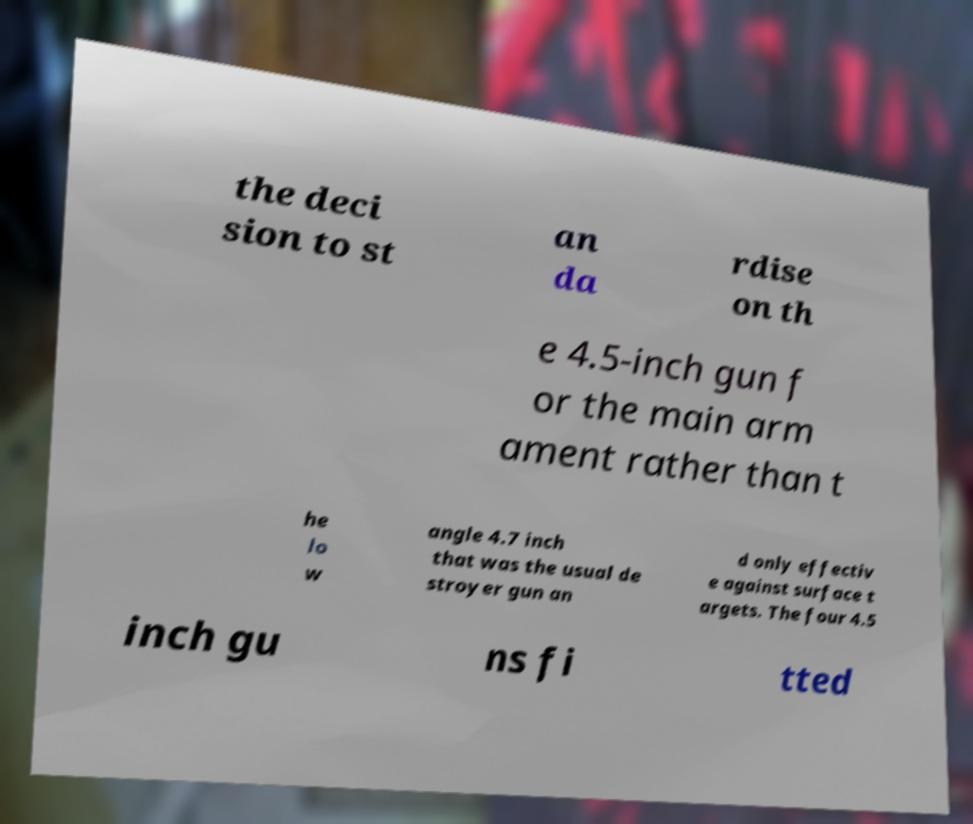What messages or text are displayed in this image? I need them in a readable, typed format. the deci sion to st an da rdise on th e 4.5-inch gun f or the main arm ament rather than t he lo w angle 4.7 inch that was the usual de stroyer gun an d only effectiv e against surface t argets. The four 4.5 inch gu ns fi tted 